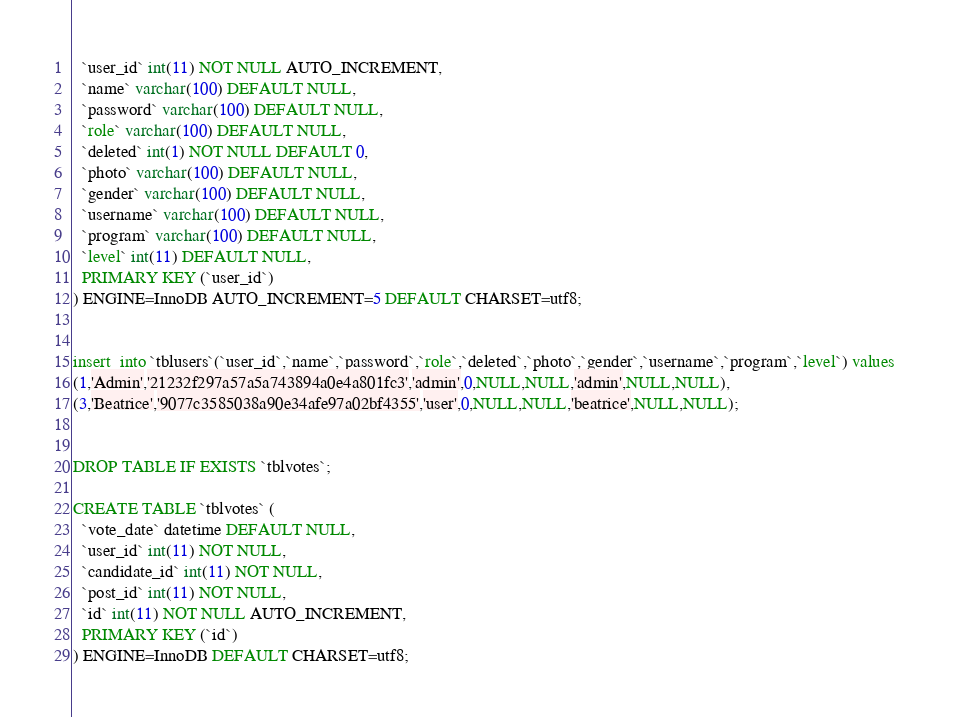<code> <loc_0><loc_0><loc_500><loc_500><_SQL_>  `user_id` int(11) NOT NULL AUTO_INCREMENT,
  `name` varchar(100) DEFAULT NULL,
  `password` varchar(100) DEFAULT NULL,
  `role` varchar(100) DEFAULT NULL,
  `deleted` int(1) NOT NULL DEFAULT 0,
  `photo` varchar(100) DEFAULT NULL,
  `gender` varchar(100) DEFAULT NULL,
  `username` varchar(100) DEFAULT NULL,
  `program` varchar(100) DEFAULT NULL,
  `level` int(11) DEFAULT NULL,
  PRIMARY KEY (`user_id`)
) ENGINE=InnoDB AUTO_INCREMENT=5 DEFAULT CHARSET=utf8;


insert  into `tblusers`(`user_id`,`name`,`password`,`role`,`deleted`,`photo`,`gender`,`username`,`program`,`level`) values 
(1,'Admin','21232f297a57a5a743894a0e4a801fc3','admin',0,NULL,NULL,'admin',NULL,NULL),
(3,'Beatrice','9077c3585038a90e34afe97a02bf4355','user',0,NULL,NULL,'beatrice',NULL,NULL);


DROP TABLE IF EXISTS `tblvotes`;

CREATE TABLE `tblvotes` (
  `vote_date` datetime DEFAULT NULL,
  `user_id` int(11) NOT NULL,
  `candidate_id` int(11) NOT NULL,
  `post_id` int(11) NOT NULL,
  `id` int(11) NOT NULL AUTO_INCREMENT,
  PRIMARY KEY (`id`)
) ENGINE=InnoDB DEFAULT CHARSET=utf8;

</code> 